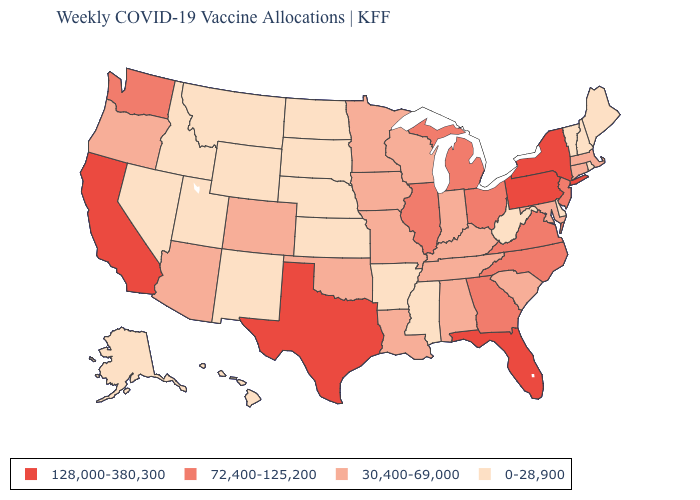What is the lowest value in states that border Louisiana?
Concise answer only. 0-28,900. What is the value of Utah?
Keep it brief. 0-28,900. What is the value of Maryland?
Write a very short answer. 30,400-69,000. Name the states that have a value in the range 72,400-125,200?
Quick response, please. Georgia, Illinois, Michigan, New Jersey, North Carolina, Ohio, Virginia, Washington. Does New Hampshire have a lower value than Nebraska?
Keep it brief. No. Name the states that have a value in the range 128,000-380,300?
Concise answer only. California, Florida, New York, Pennsylvania, Texas. What is the value of Idaho?
Write a very short answer. 0-28,900. Does Michigan have the same value as Wyoming?
Keep it brief. No. Name the states that have a value in the range 0-28,900?
Be succinct. Alaska, Arkansas, Delaware, Hawaii, Idaho, Kansas, Maine, Mississippi, Montana, Nebraska, Nevada, New Hampshire, New Mexico, North Dakota, Rhode Island, South Dakota, Utah, Vermont, West Virginia, Wyoming. Does Utah have the highest value in the USA?
Be succinct. No. Does Arizona have a higher value than Mississippi?
Answer briefly. Yes. Which states hav the highest value in the West?
Write a very short answer. California. Name the states that have a value in the range 30,400-69,000?
Answer briefly. Alabama, Arizona, Colorado, Connecticut, Indiana, Iowa, Kentucky, Louisiana, Maryland, Massachusetts, Minnesota, Missouri, Oklahoma, Oregon, South Carolina, Tennessee, Wisconsin. Which states have the lowest value in the USA?
Concise answer only. Alaska, Arkansas, Delaware, Hawaii, Idaho, Kansas, Maine, Mississippi, Montana, Nebraska, Nevada, New Hampshire, New Mexico, North Dakota, Rhode Island, South Dakota, Utah, Vermont, West Virginia, Wyoming. What is the value of Indiana?
Quick response, please. 30,400-69,000. 